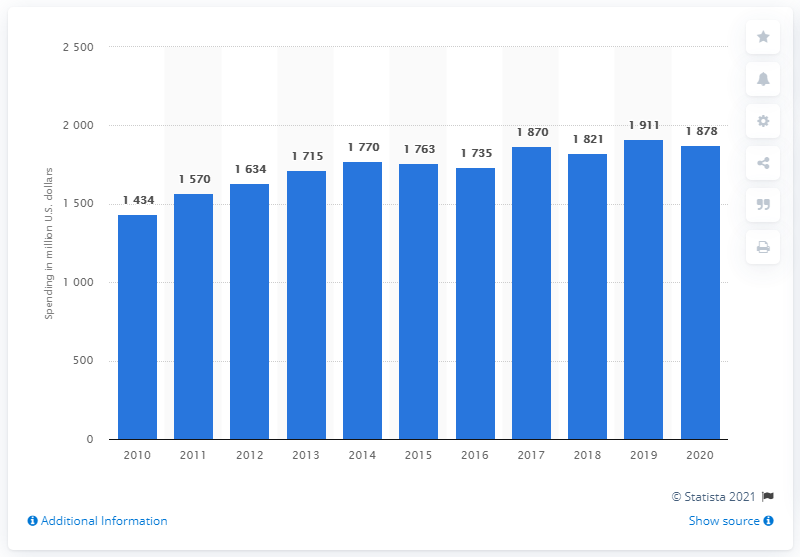Indicate a few pertinent items in this graphic. In 2020, 3M dedicated $1911 million towards research and development efforts. 